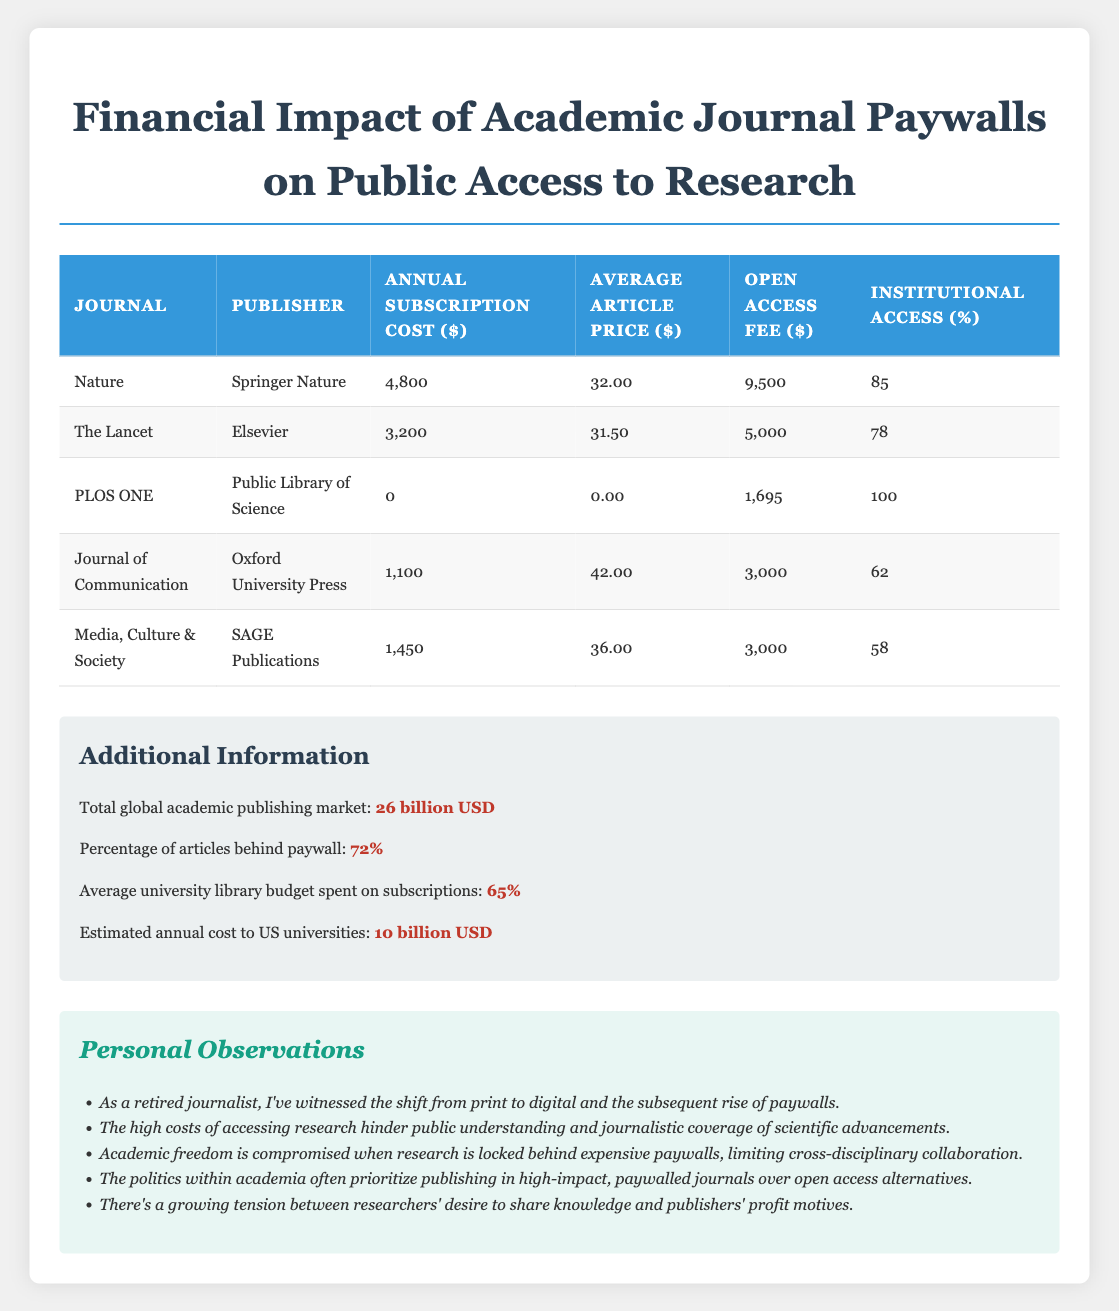What is the annual subscription cost for the journal Nature? The table lists the annual subscription cost for Nature as 4800 dollars, which can be found directly under the "Annual Subscription Cost" column for Nature.
Answer: 4800 What is the average article price for The Lancet? The average article price for The Lancet is listed as 31.50 dollars in the corresponding row of the table under the "Average Article Price" column.
Answer: 31.50 Which journal has the highest open access fee? Comparing the open access fees listed in the table, Nature has the highest open access fee at 9500 dollars, which is the maximum value in the "Open Access Fee" column.
Answer: 9500 What percentage of articles is behind a paywall? According to the additional information provided, 72 percent of articles are behind a paywall, which is stated as a fact.
Answer: 72% Which journal offers 100% institutional access? The table indicates that PLOS ONE offers 100% institutional access, as recorded under the "Institutional Access (%)" column for PLOS ONE.
Answer: PLOS ONE Calculate the average annual subscription cost of the journals listed. The annual subscription costs are 4800, 3200, 0, 1100, and 1450 dollars. Summing these yields 4800 + 3200 + 0 + 1100 + 1450 = 10550 dollars. Dividing by 5 (the number of journals) gives an average of 2110 dollars.
Answer: 2110 Is the annual subscription cost for the Journal of Communication greater than that of Media, Culture & Society? The annual subscription cost for the Journal of Communication is 1100 dollars, whereas Media, Culture & Society has a cost of 1450 dollars. Since 1100 is not greater than 1450, the answer is no.
Answer: No Which publisher has the lowest average article price? Referencing the average article prices from the table, PLOS ONE shows an average article price of 0 dollars, which is the lowest. Therefore, the publisher associated with this journal is the Public Library of Science.
Answer: Public Library of Science What is the total cost to US universities on average for subscriptions to these journals? The additional information states that the estimated annual cost to US universities is 10 billion dollars, which is a specific value provided separately from the table data.
Answer: 10 billion USD 